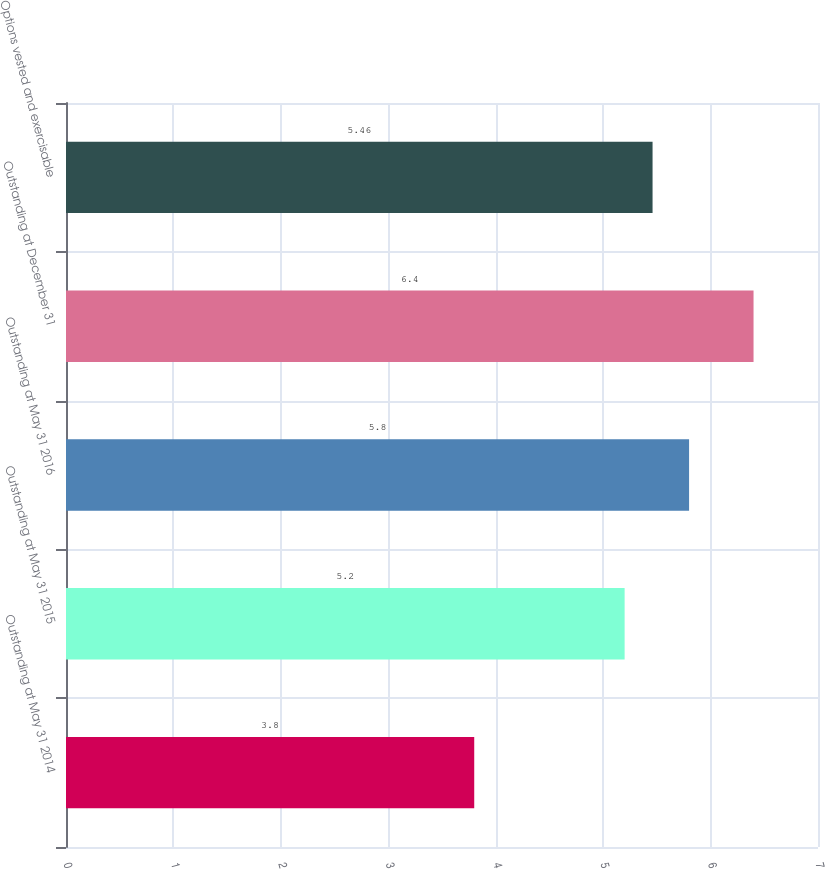Convert chart to OTSL. <chart><loc_0><loc_0><loc_500><loc_500><bar_chart><fcel>Outstanding at May 31 2014<fcel>Outstanding at May 31 2015<fcel>Outstanding at May 31 2016<fcel>Outstanding at December 31<fcel>Options vested and exercisable<nl><fcel>3.8<fcel>5.2<fcel>5.8<fcel>6.4<fcel>5.46<nl></chart> 